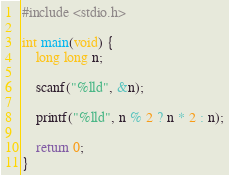<code> <loc_0><loc_0><loc_500><loc_500><_C_>#include <stdio.h>

int main(void) {
	long long n;
	
	scanf("%lld", &n);
	
	printf("%lld", n % 2 ? n * 2 : n);
	
	return 0;
}</code> 